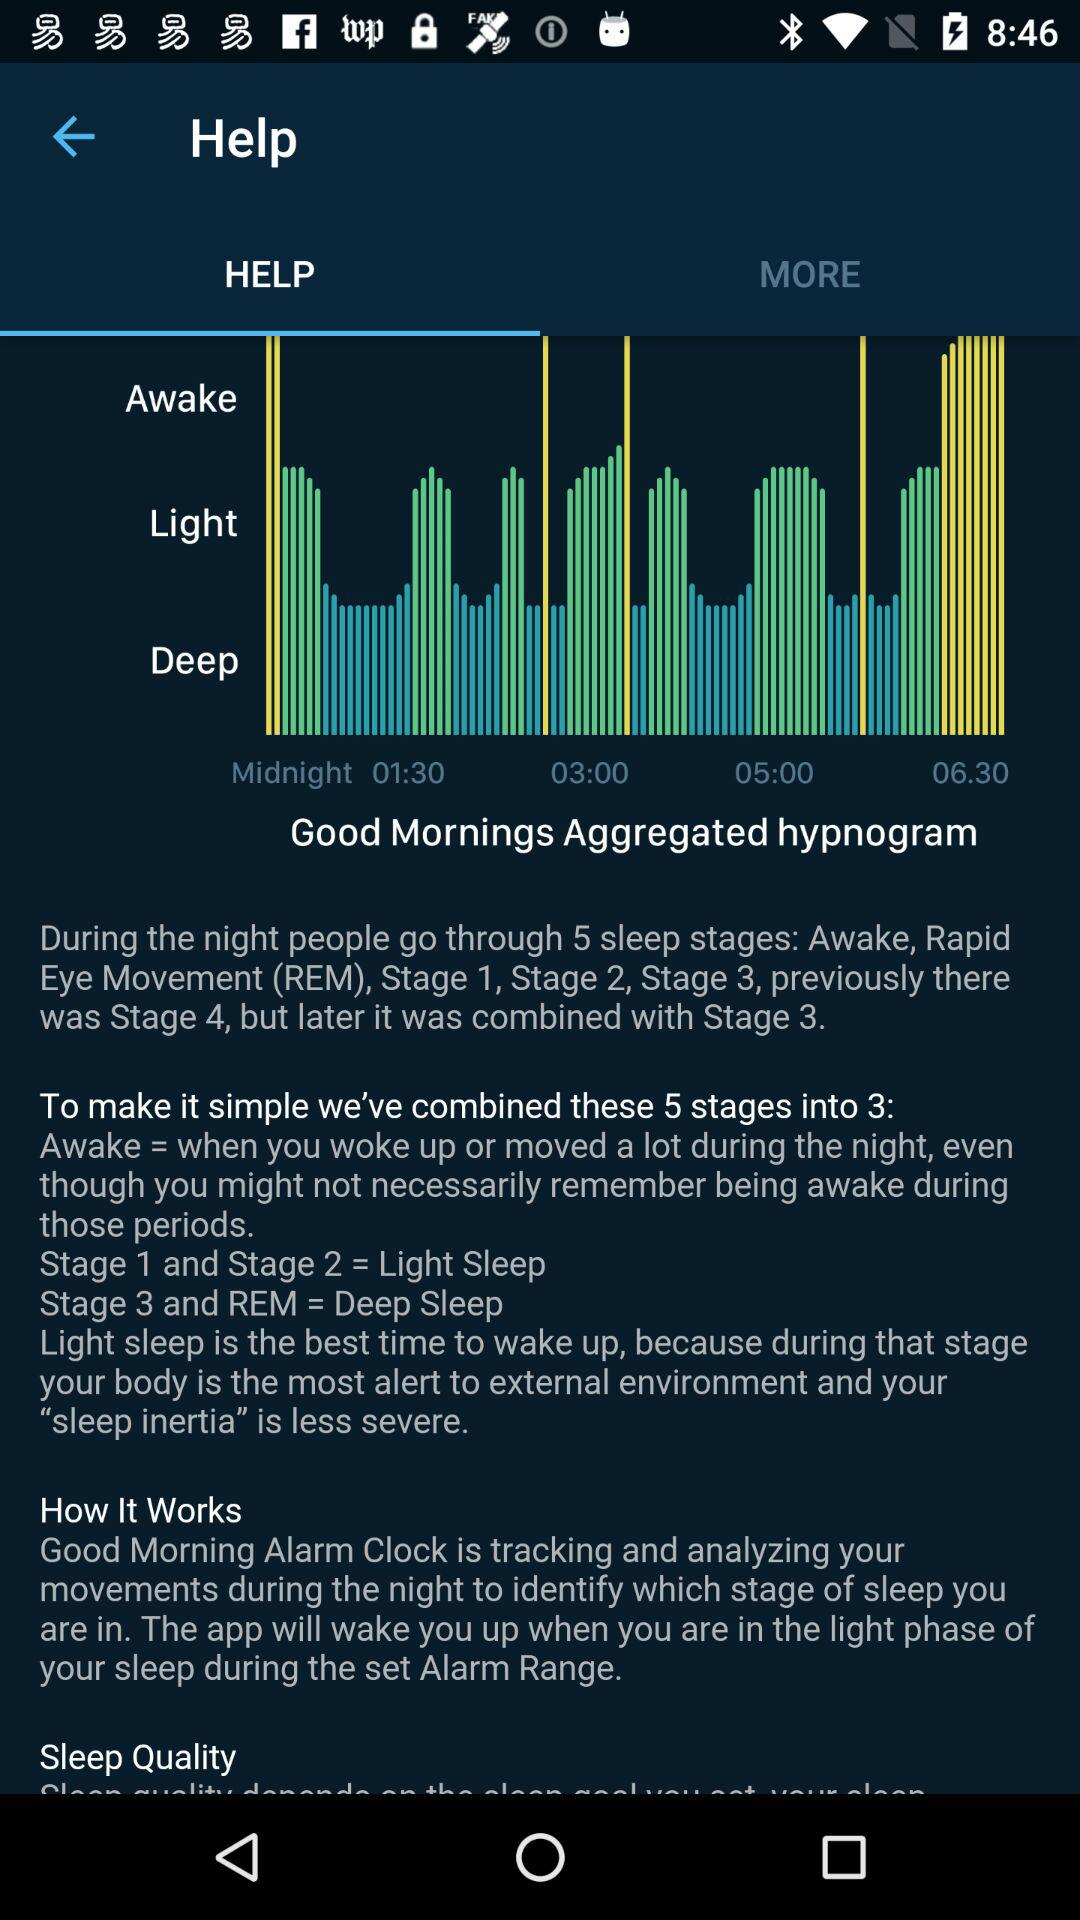How many stages of sleep are described in the text?
Answer the question using a single word or phrase. 3 